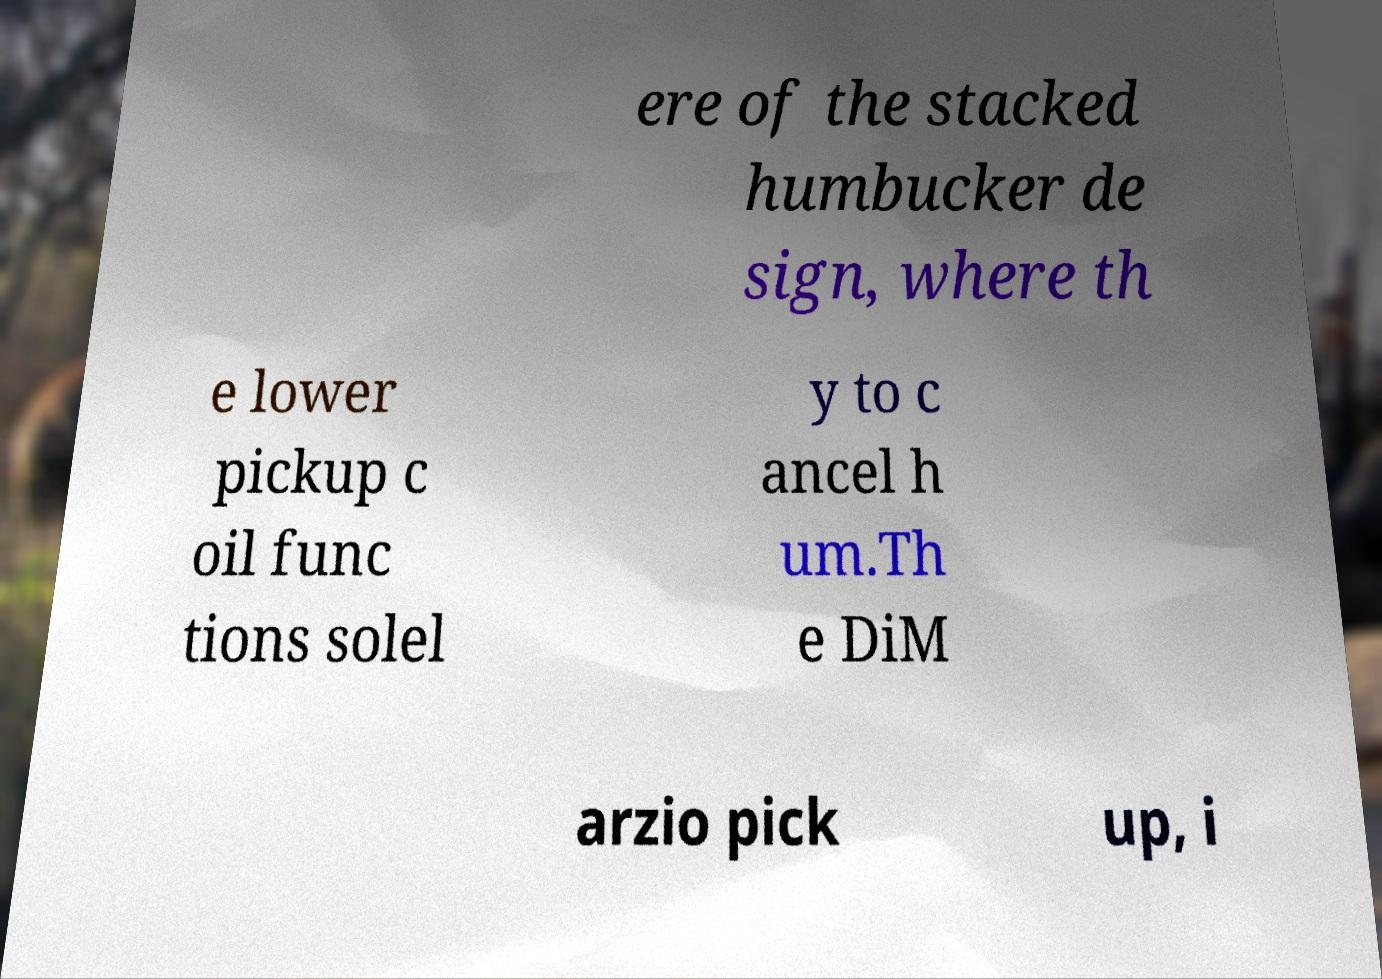For documentation purposes, I need the text within this image transcribed. Could you provide that? ere of the stacked humbucker de sign, where th e lower pickup c oil func tions solel y to c ancel h um.Th e DiM arzio pick up, i 